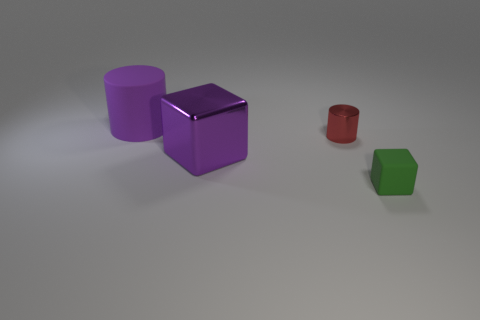The matte thing in front of the big object behind the block that is left of the green block is what shape?
Make the answer very short. Cube. There is a block that is on the left side of the matte cube; does it have the same color as the rubber object that is behind the tiny green rubber block?
Give a very brief answer. Yes. Is the number of matte cubes behind the small block less than the number of tiny red objects in front of the purple cube?
Offer a very short reply. No. Is there any other thing that is the same shape as the tiny rubber object?
Offer a terse response. Yes. What color is the metal object that is the same shape as the large matte thing?
Make the answer very short. Red. There is a big rubber thing; does it have the same shape as the small object that is to the left of the small rubber block?
Keep it short and to the point. Yes. How many things are either tiny green rubber cubes in front of the purple metal thing or small green things that are to the right of the matte cylinder?
Provide a short and direct response. 1. What material is the purple block?
Offer a very short reply. Metal. How many other things are there of the same size as the purple cylinder?
Keep it short and to the point. 1. What size is the cylinder left of the tiny red object?
Offer a terse response. Large. 